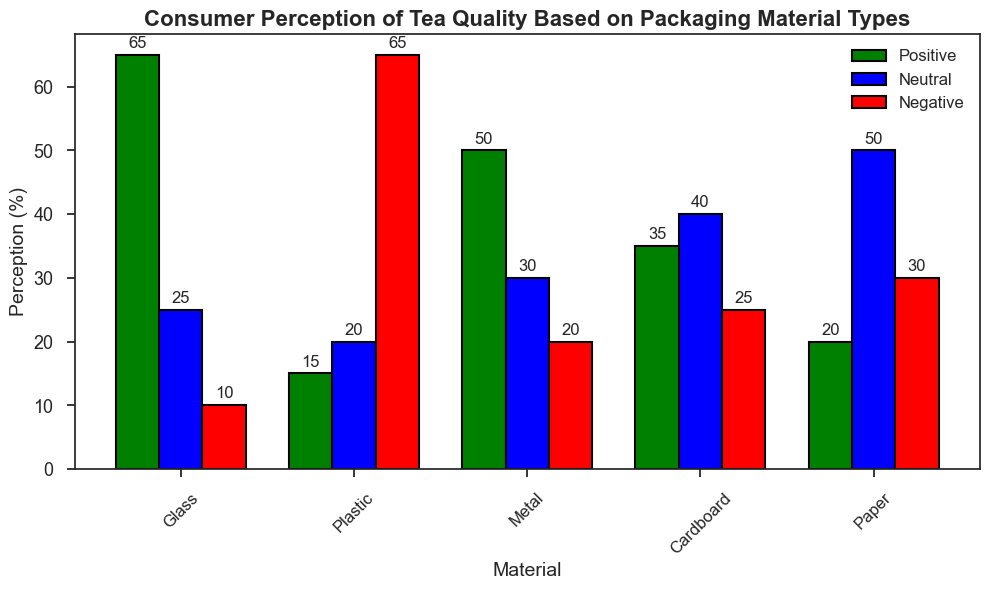What's the material with the highest positive perception? Look at the green bars representing the positive perception for all materials. Glass has the highest bar at 65%.
Answer: Glass Which material has a higher negative perception, plastic or metal? Compare the red bars representing the negative perception for both plastic and metal. Plastic has a negative perception of 65%, while metal has 20%.
Answer: Plastic What's the difference in positive perception between glass and cardboard? Glass has a positive perception of 65%, and cardboard has 35%. The difference is 65% - 35%.
Answer: 30% Which material has the highest neutral perception? Look at the blue bars representing the neutral perception for all materials. Paper has the highest at 50%.
Answer: Paper Combine the positive and neutral perceptions for metal. What's the total? Metal has a positive perception of 50% and a neutral perception of 30%. Add them together, 50% + 30%.
Answer: 80% For which material is the positive perception closest to 50%? Check the green bars to find the one closest to 50%. Metal has a positive perception of exactly 50%.
Answer: Metal Which two materials have the same negative perception, and what is it? Look at the red bars for matching heights. Both metal and cardboard have a negative perception of 20%.
Answer: Metal and cardboard, 20% Order the materials by their neutral perception from highest to lowest. Paper (50%), Cardboard (40%), Metal (30%), Plastic (20%), Glass (25%). Order these values from highest to lowest.
Answer: Paper, Cardboard, Metal, Glass, Plastic What is the total perception percentage for glass across all categories (positive, neutral, and negative)? Sum the perceptions for glass: 65% (positive) + 25% (neutral) + 10% (negative).
Answer: 100% Is there any material where the neutral perception is at least double the positive perception? Compare the neutral and positive perceptions for each material. For paper, the neutral perception is 50% and the positive is 20%. 50% is more than double 20%.
Answer: Paper 